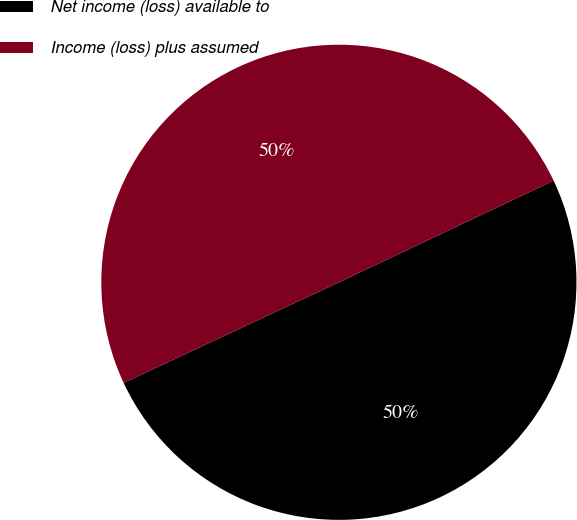Convert chart. <chart><loc_0><loc_0><loc_500><loc_500><pie_chart><fcel>Net income (loss) available to<fcel>Income (loss) plus assumed<nl><fcel>50.08%<fcel>49.92%<nl></chart> 